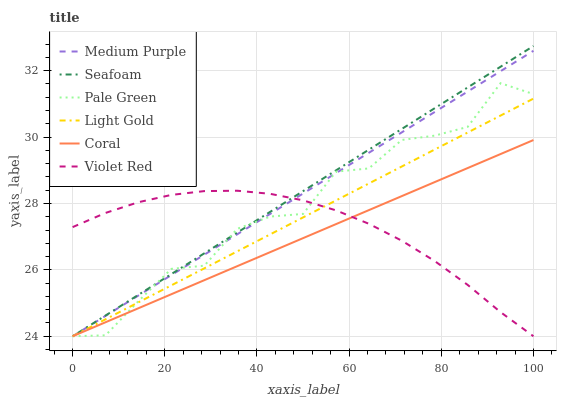Does Coral have the minimum area under the curve?
Answer yes or no. Yes. Does Seafoam have the maximum area under the curve?
Answer yes or no. Yes. Does Seafoam have the minimum area under the curve?
Answer yes or no. No. Does Coral have the maximum area under the curve?
Answer yes or no. No. Is Seafoam the smoothest?
Answer yes or no. Yes. Is Pale Green the roughest?
Answer yes or no. Yes. Is Coral the smoothest?
Answer yes or no. No. Is Coral the roughest?
Answer yes or no. No. Does Violet Red have the lowest value?
Answer yes or no. Yes. Does Seafoam have the highest value?
Answer yes or no. Yes. Does Coral have the highest value?
Answer yes or no. No. Does Pale Green intersect Seafoam?
Answer yes or no. Yes. Is Pale Green less than Seafoam?
Answer yes or no. No. Is Pale Green greater than Seafoam?
Answer yes or no. No. 